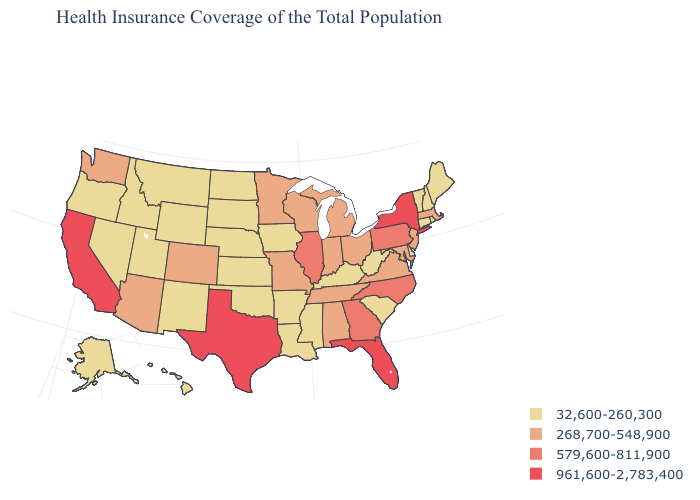Among the states that border Virginia , does Kentucky have the lowest value?
Keep it brief. Yes. What is the lowest value in states that border North Dakota?
Short answer required. 32,600-260,300. Among the states that border Iowa , which have the highest value?
Short answer required. Illinois. Among the states that border Missouri , which have the highest value?
Short answer required. Illinois. What is the value of Washington?
Quick response, please. 268,700-548,900. What is the lowest value in the South?
Give a very brief answer. 32,600-260,300. Which states have the lowest value in the USA?
Be succinct. Alaska, Arkansas, Connecticut, Delaware, Hawaii, Idaho, Iowa, Kansas, Kentucky, Louisiana, Maine, Mississippi, Montana, Nebraska, Nevada, New Hampshire, New Mexico, North Dakota, Oklahoma, Oregon, Rhode Island, South Carolina, South Dakota, Utah, Vermont, West Virginia, Wyoming. Which states have the highest value in the USA?
Concise answer only. California, Florida, New York, Texas. Does Maryland have the lowest value in the USA?
Be succinct. No. Does Texas have the highest value in the South?
Be succinct. Yes. Does Virginia have the lowest value in the USA?
Concise answer only. No. Which states hav the highest value in the West?
Short answer required. California. Name the states that have a value in the range 579,600-811,900?
Write a very short answer. Georgia, Illinois, North Carolina, Pennsylvania. Among the states that border Virginia , which have the highest value?
Quick response, please. North Carolina. Among the states that border Illinois , which have the highest value?
Quick response, please. Indiana, Missouri, Wisconsin. 